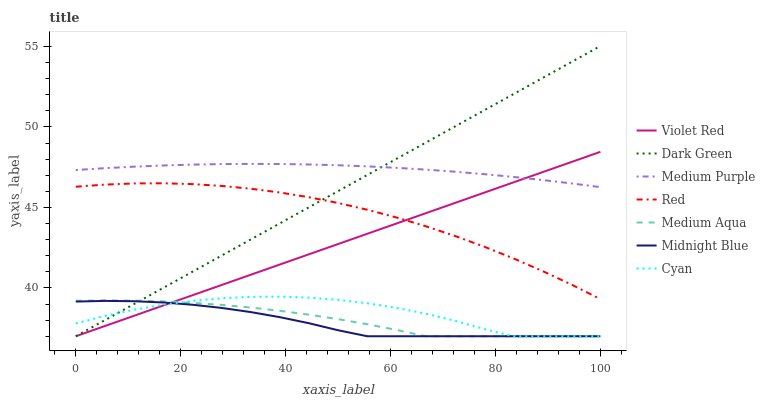Does Midnight Blue have the minimum area under the curve?
Answer yes or no. Yes. Does Medium Purple have the maximum area under the curve?
Answer yes or no. Yes. Does Medium Purple have the minimum area under the curve?
Answer yes or no. No. Does Midnight Blue have the maximum area under the curve?
Answer yes or no. No. Is Dark Green the smoothest?
Answer yes or no. Yes. Is Cyan the roughest?
Answer yes or no. Yes. Is Midnight Blue the smoothest?
Answer yes or no. No. Is Midnight Blue the roughest?
Answer yes or no. No. Does Medium Purple have the lowest value?
Answer yes or no. No. Does Medium Purple have the highest value?
Answer yes or no. No. Is Medium Aqua less than Medium Purple?
Answer yes or no. Yes. Is Medium Purple greater than Medium Aqua?
Answer yes or no. Yes. Does Medium Aqua intersect Medium Purple?
Answer yes or no. No. 